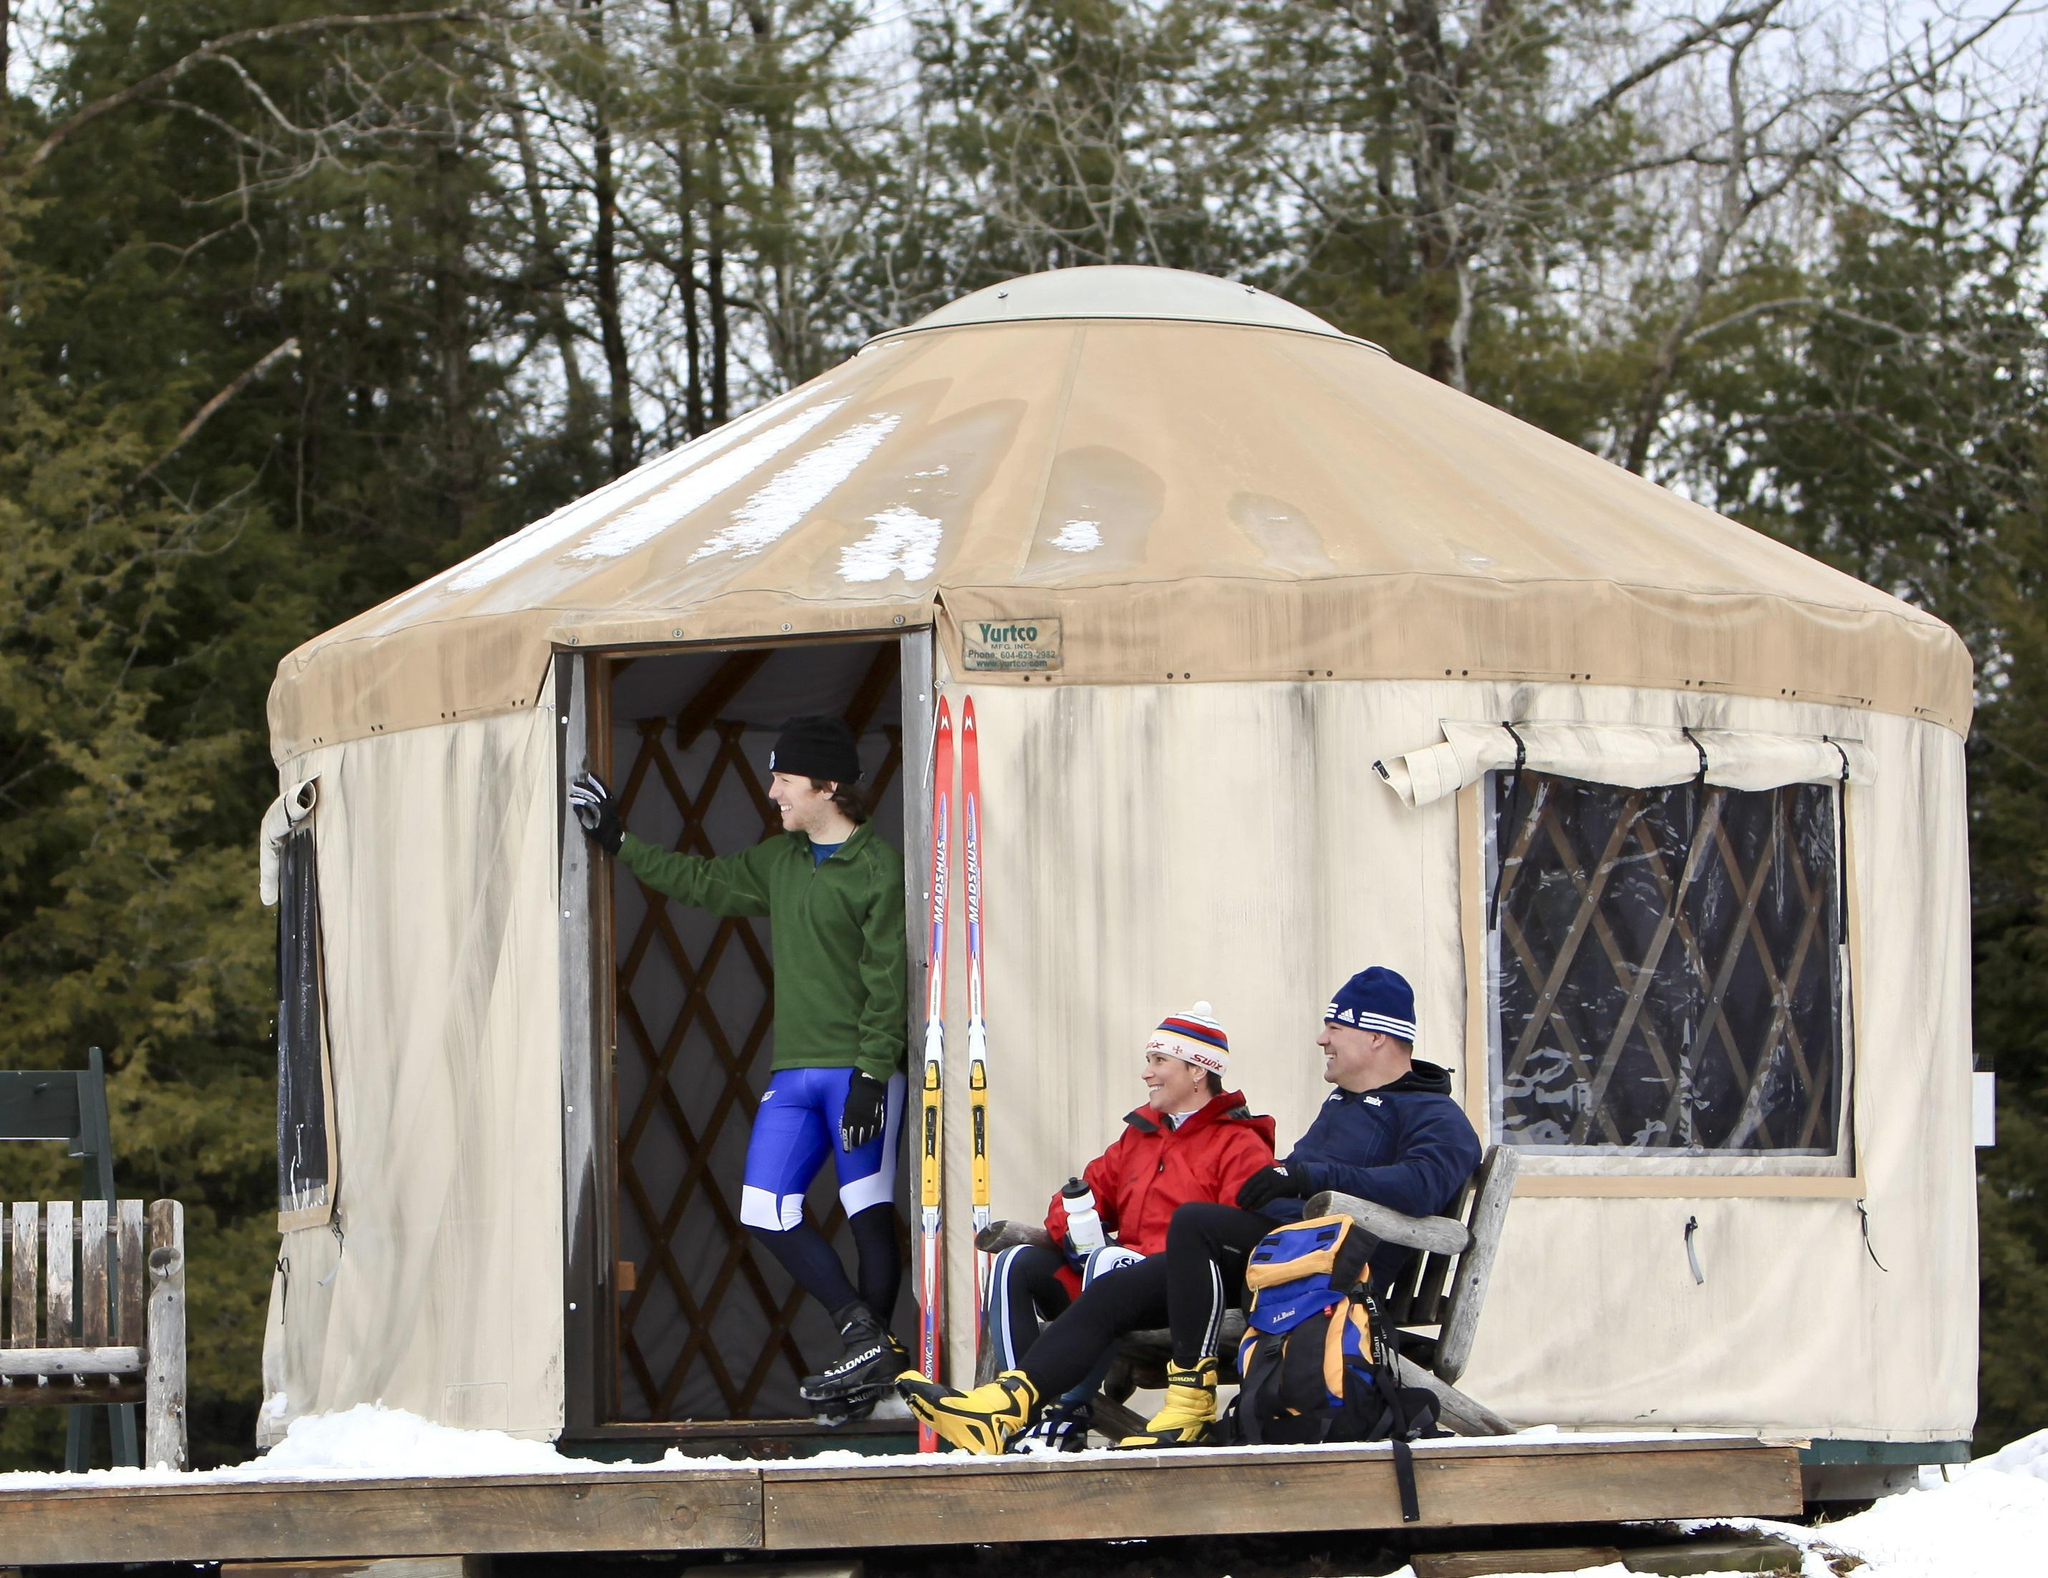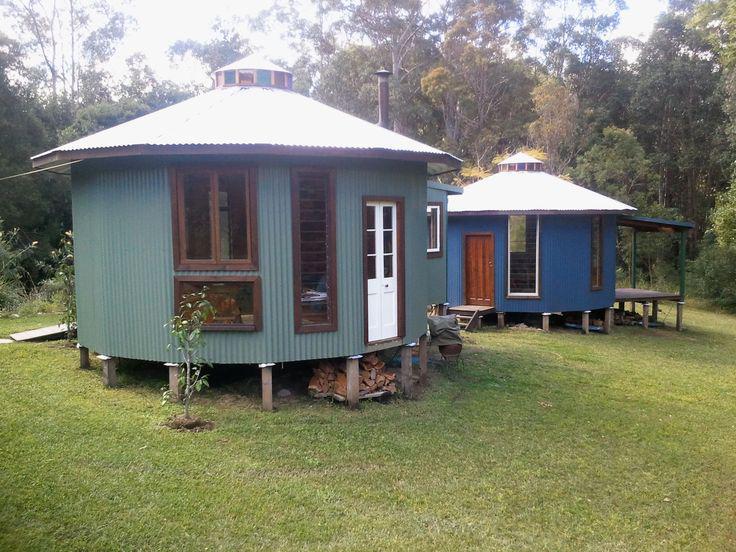The first image is the image on the left, the second image is the image on the right. Evaluate the accuracy of this statement regarding the images: "Smoke is coming out of the chimney at the right side of a round building.". Is it true? Answer yes or no. No. The first image is the image on the left, the second image is the image on the right. Assess this claim about the two images: "One of the images contains a cottage with smoke coming out of its chimney.". Correct or not? Answer yes or no. No. 